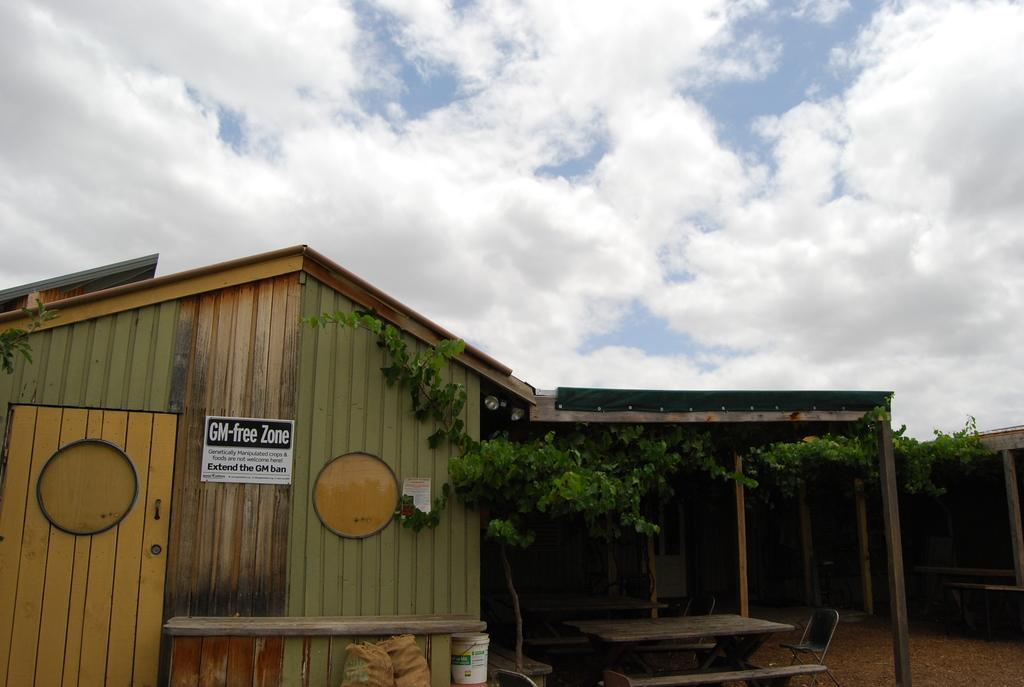Could you give a brief overview of what you see in this image? In this image I can see a wooden house with stone pillars and a plant and at the top of the image I can see the sky.  